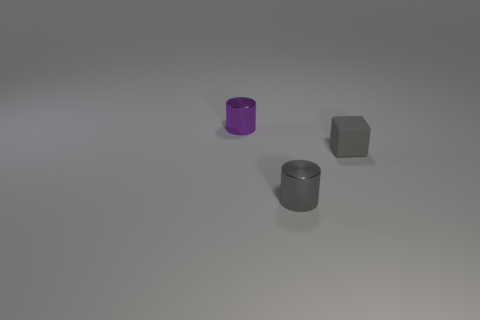Is there any other thing that is the same material as the purple thing?
Provide a short and direct response. Yes. What is the color of the small metal object left of the metal cylinder that is in front of the small cube?
Ensure brevity in your answer.  Purple. How many cylinders are both in front of the purple object and on the left side of the gray cylinder?
Offer a very short reply. 0. Are there more small shiny cylinders than objects?
Provide a succinct answer. No. What is the material of the gray cube?
Provide a short and direct response. Rubber. There is a gray object that is in front of the tiny cube; how many small gray things are right of it?
Provide a short and direct response. 1. Is the color of the cube the same as the cylinder that is in front of the small purple object?
Your answer should be very brief. Yes. What color is the other shiny object that is the same size as the purple metallic thing?
Your answer should be compact. Gray. Is there another thing of the same shape as the small purple metal thing?
Keep it short and to the point. Yes. Is the number of brown rubber spheres less than the number of small gray rubber things?
Offer a terse response. Yes. 